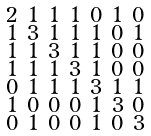<formula> <loc_0><loc_0><loc_500><loc_500>\begin{smallmatrix} 2 & 1 & 1 & 1 & 0 & 1 & 0 \\ 1 & 3 & 1 & 1 & 1 & 0 & 1 \\ 1 & 1 & 3 & 1 & 1 & 0 & 0 \\ 1 & 1 & 1 & 3 & 1 & 0 & 0 \\ 0 & 1 & 1 & 1 & 3 & 1 & 1 \\ 1 & 0 & 0 & 0 & 1 & 3 & 0 \\ 0 & 1 & 0 & 0 & 1 & 0 & 3 \end{smallmatrix}</formula> 